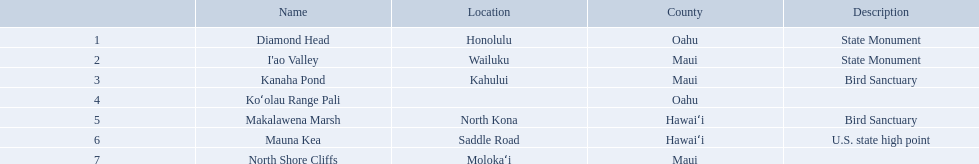What are all of the landmark names? Diamond Head, I'ao Valley, Kanaha Pond, Koʻolau Range Pali, Makalawena Marsh, Mauna Kea, North Shore Cliffs. Where are they located? Honolulu, Wailuku, Kahului, , North Kona, Saddle Road, Molokaʻi. And which landmark has no listed location? Koʻolau Range Pali. What are the names of the different hawaiian national landmarks Diamond Head, I'ao Valley, Kanaha Pond, Koʻolau Range Pali, Makalawena Marsh, Mauna Kea, North Shore Cliffs. Which landmark does not have a location listed? Koʻolau Range Pali. 